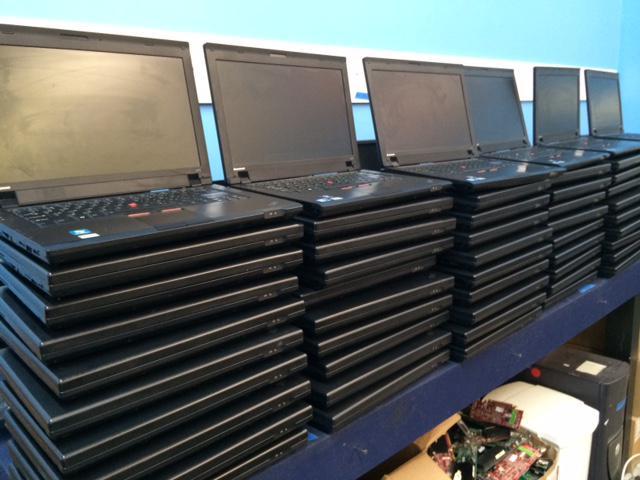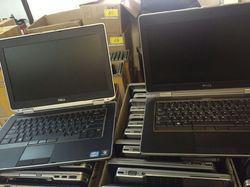The first image is the image on the left, the second image is the image on the right. Evaluate the accuracy of this statement regarding the images: "At least one image shows stacks of devices.". Is it true? Answer yes or no. Yes. The first image is the image on the left, the second image is the image on the right. For the images displayed, is the sentence "Some laptops are stacked in multiple rows at least four to a stack." factually correct? Answer yes or no. Yes. 